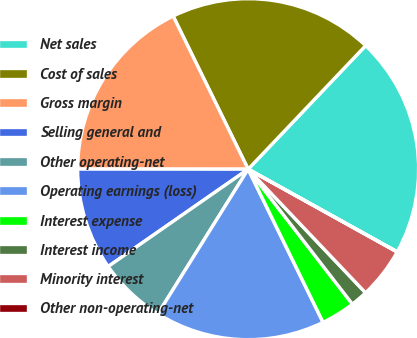Convert chart. <chart><loc_0><loc_0><loc_500><loc_500><pie_chart><fcel>Net sales<fcel>Cost of sales<fcel>Gross margin<fcel>Selling general and<fcel>Other operating-net<fcel>Operating earnings (loss)<fcel>Interest expense<fcel>Interest income<fcel>Minority interest<fcel>Other non-operating-net<nl><fcel>20.96%<fcel>19.35%<fcel>17.74%<fcel>9.68%<fcel>6.45%<fcel>16.12%<fcel>3.23%<fcel>1.62%<fcel>4.84%<fcel>0.01%<nl></chart> 